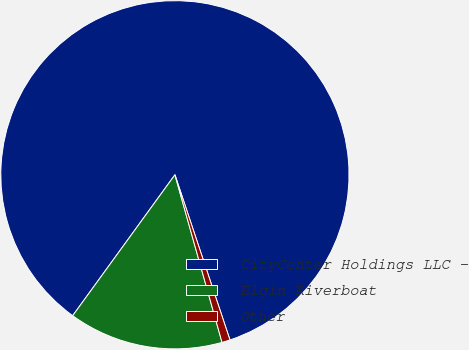<chart> <loc_0><loc_0><loc_500><loc_500><pie_chart><fcel>CityCenter Holdings LLC -<fcel>Elgin Riverboat<fcel>Other<nl><fcel>84.89%<fcel>14.35%<fcel>0.76%<nl></chart> 